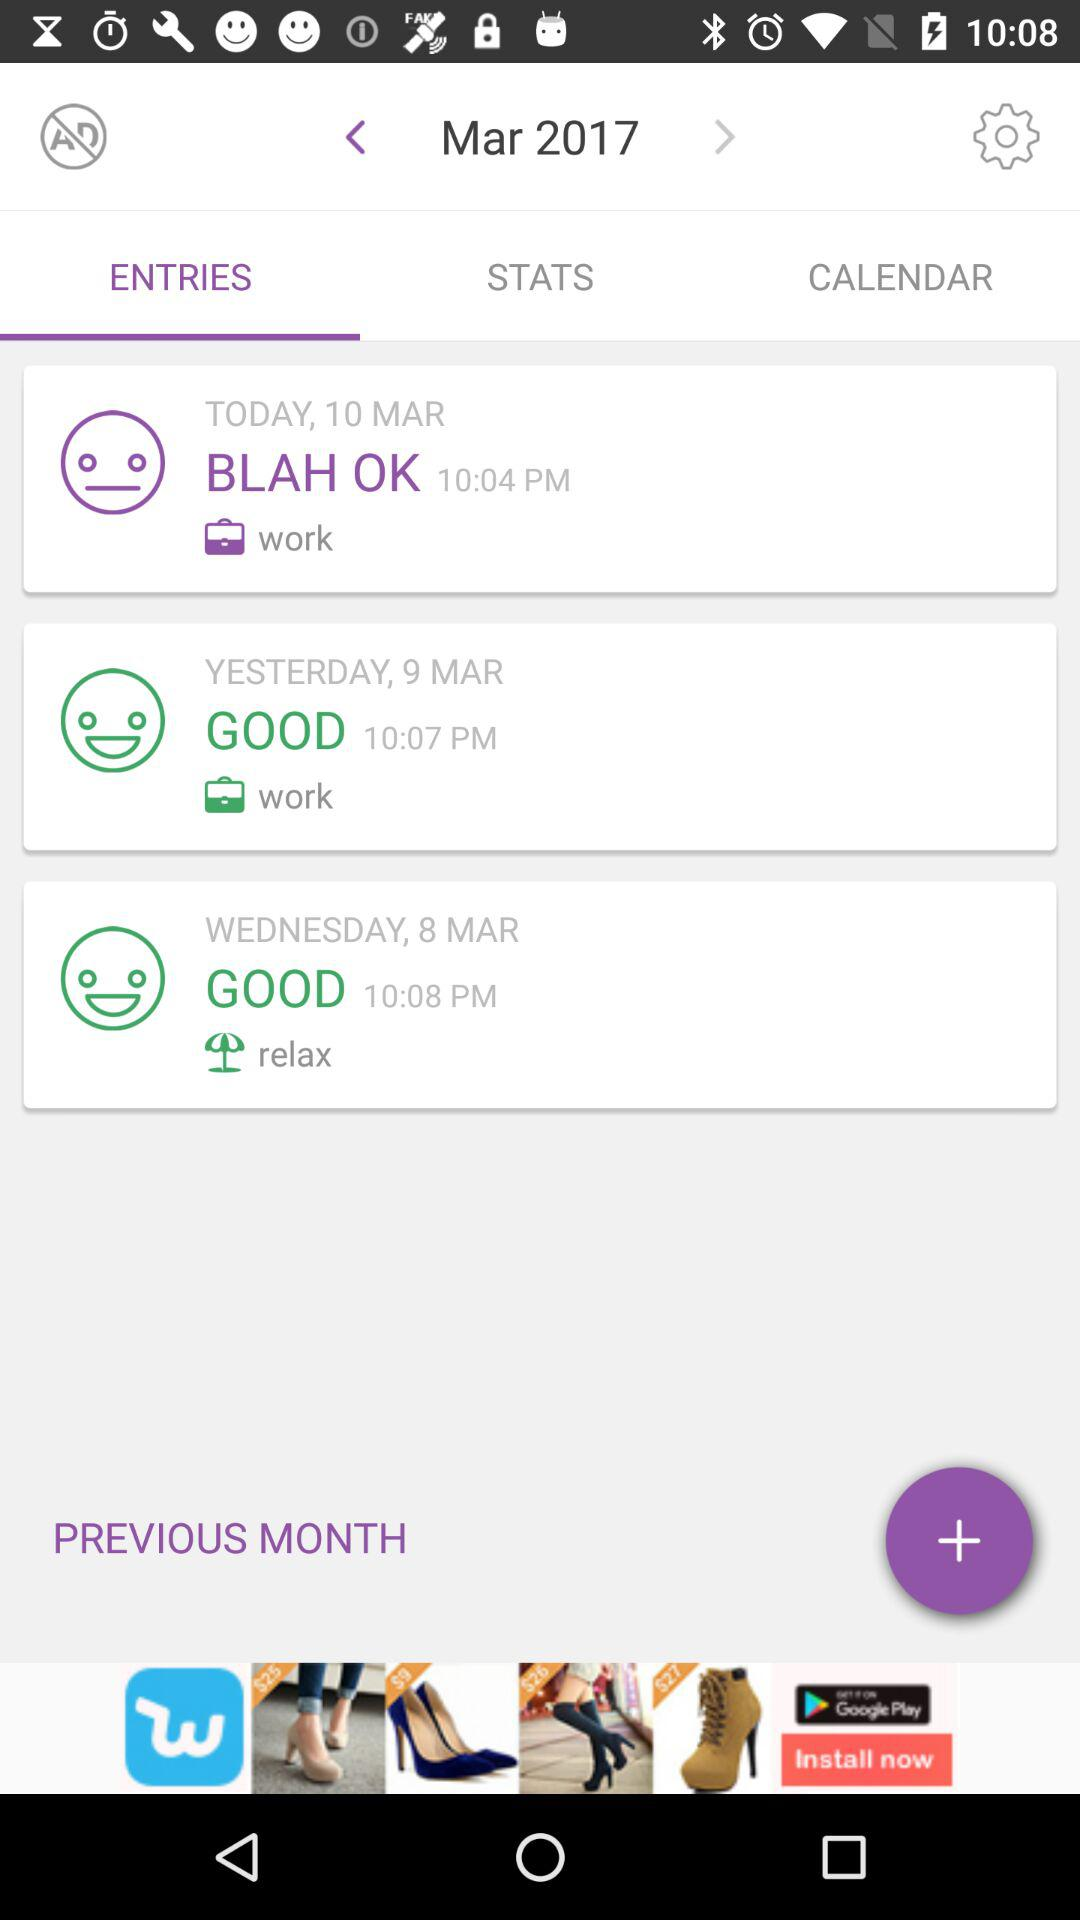What was yesterday's rating? The rating was good. 